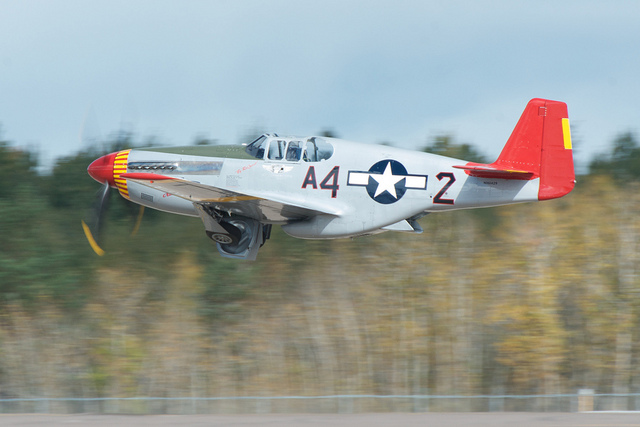Is there a star in the scene? Yes, there is a star visible in the scene. It's part of the markings on the fuselage of the aircraft, which is a classic insignia known as a 'star-and-bar' used to identify military aircraft belonging to the United States. 